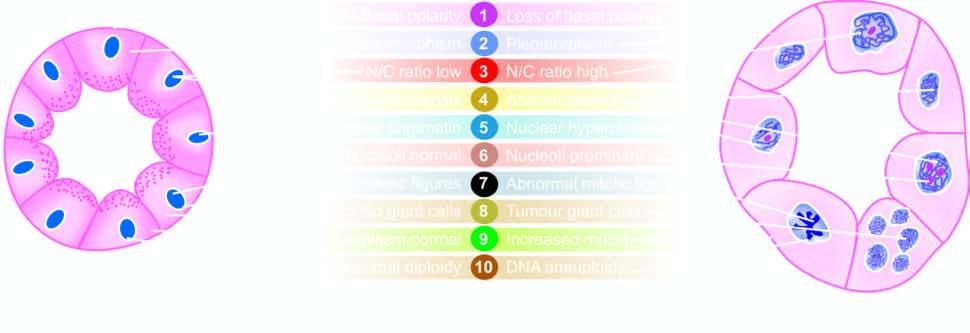re premitotic phases contrasted with the appearance of an acinus?
Answer the question using a single word or phrase. No 